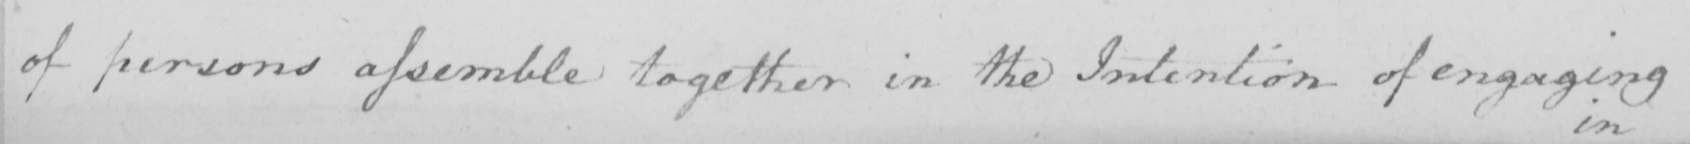Can you tell me what this handwritten text says? of persons assemble together in the Intention of engaging 